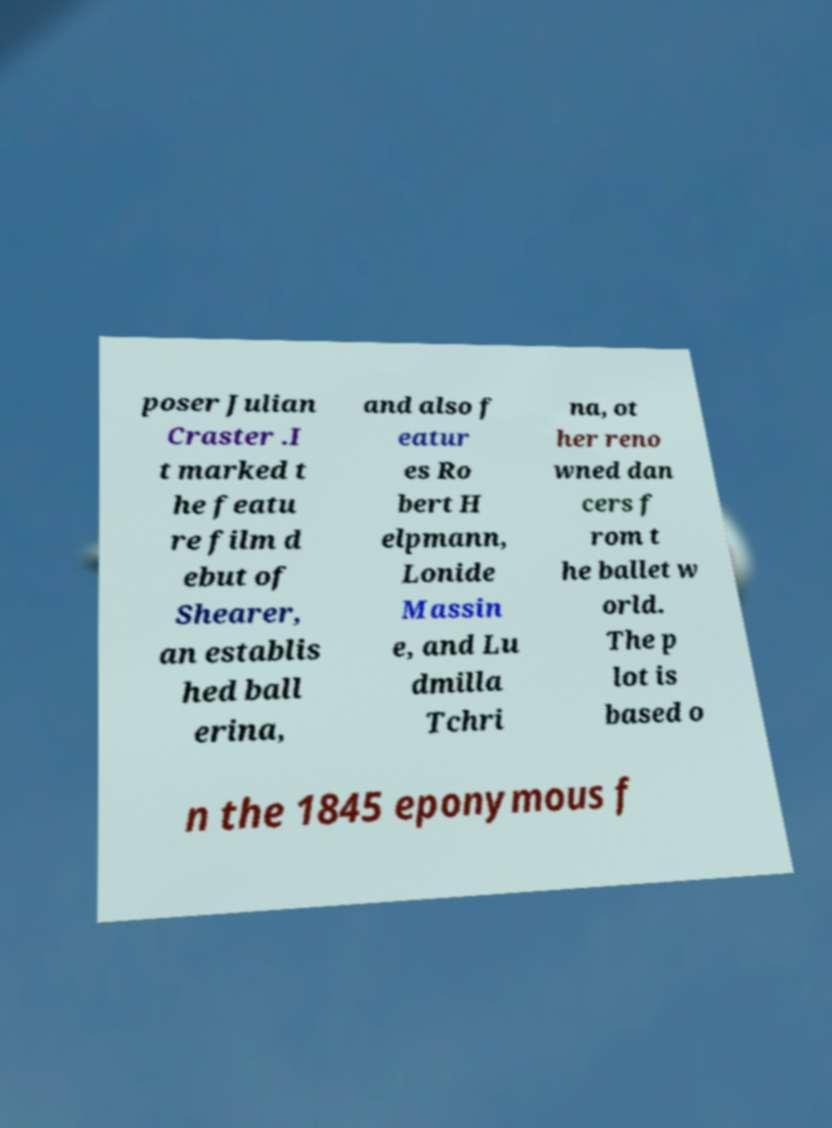Please identify and transcribe the text found in this image. poser Julian Craster .I t marked t he featu re film d ebut of Shearer, an establis hed ball erina, and also f eatur es Ro bert H elpmann, Lonide Massin e, and Lu dmilla Tchri na, ot her reno wned dan cers f rom t he ballet w orld. The p lot is based o n the 1845 eponymous f 